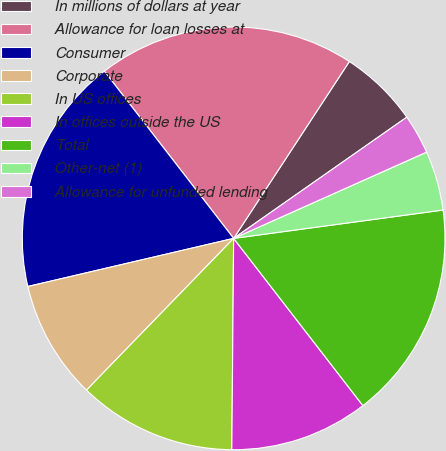<chart> <loc_0><loc_0><loc_500><loc_500><pie_chart><fcel>In millions of dollars at year<fcel>Allowance for loan losses at<fcel>Consumer<fcel>Corporate<fcel>In US offices<fcel>In offices outside the US<fcel>Total<fcel>Other-net (1)<fcel>Allowance for unfunded lending<nl><fcel>6.06%<fcel>19.7%<fcel>18.18%<fcel>9.09%<fcel>12.12%<fcel>10.61%<fcel>16.67%<fcel>4.55%<fcel>3.03%<nl></chart> 